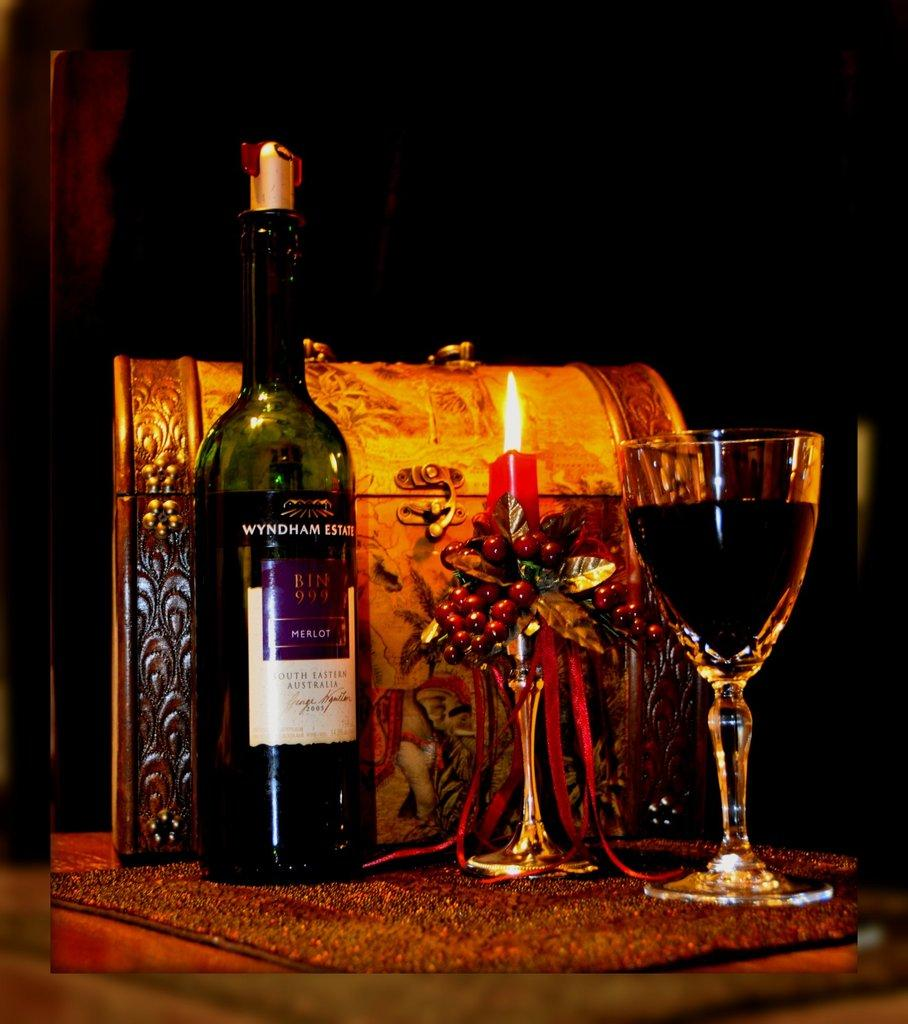What is one of the items on the table in the image? There is a bottle in the image. What is another item on the table in the image? There is a candle in the image. What is the third item on the table in the image? There is a glass of wine in the image. Where are all these items located in the image? All items are on a table. What historical event is being taught in the image? There is no indication of any historical event or teaching in the image; it simply shows a bottle, a candle, and a glass of wine on a table. 